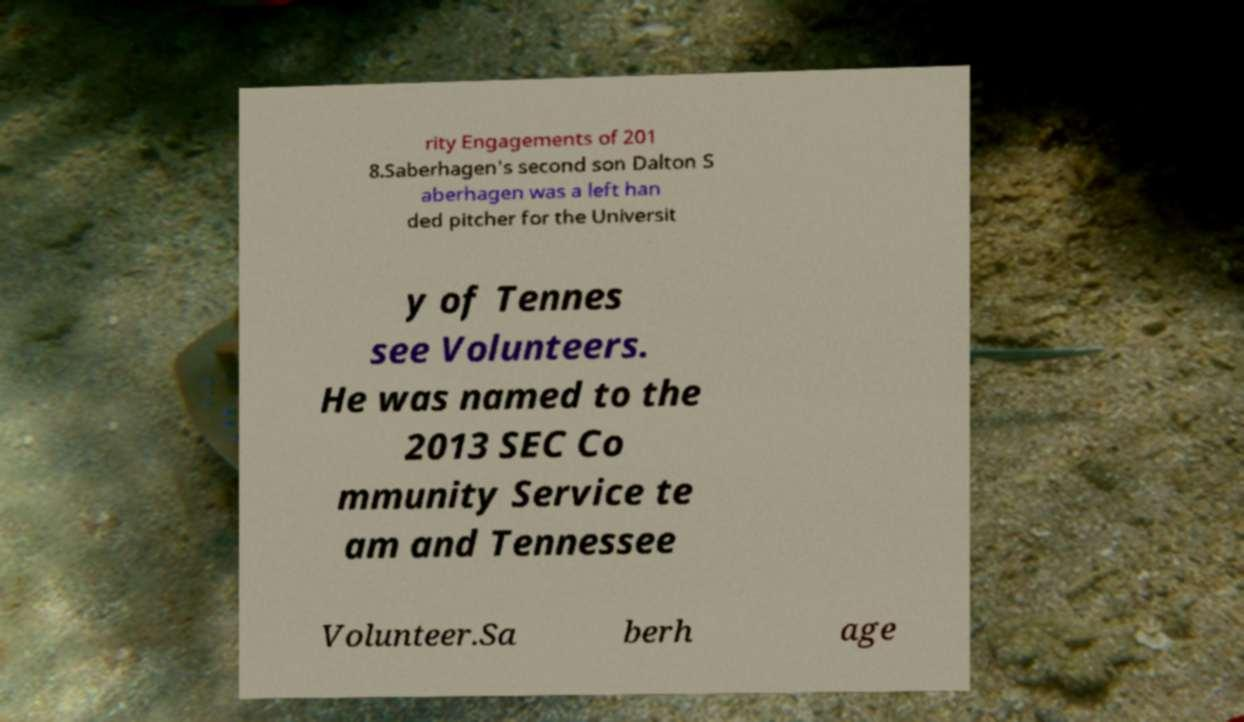Can you accurately transcribe the text from the provided image for me? rity Engagements of 201 8.Saberhagen's second son Dalton S aberhagen was a left han ded pitcher for the Universit y of Tennes see Volunteers. He was named to the 2013 SEC Co mmunity Service te am and Tennessee Volunteer.Sa berh age 